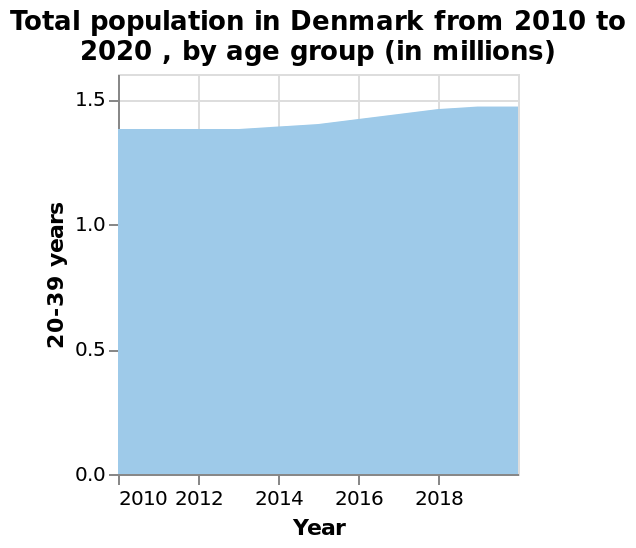<image>
please summary the statistics and relations of the chart Total population in Denmark from 2010 to 2020 has increased. Between 2010 and 2013 the population was stable, then it began to increase. Population appears to have stabilised again for 2019 and 2020. Which country does the area chart refer to? The area chart refers to Denmark. Offer a thorough analysis of the image. The number of 20-39 year olds in Denmark has been slowly increasing between 2010 and 2020. The highest number is reached in 2020 where number of 20-39 year olds reaches almost 1.5 million. What does the x-axis represent in the graph? The x-axis represents the years from 2010 to 2020. What age group has the highest number in 2020 in Denmark? The 20-39 year old age group has the highest number in 2020. How many 20-39 year olds are there in Denmark in 2020? Almost 1.5 million 20-39 year olds are there in Denmark in 2020. What age group is plotted on the y-axis of the chart? The age group plotted on the y-axis of the chart is 20-39 years. 